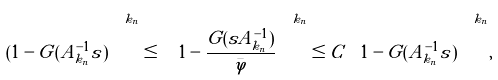<formula> <loc_0><loc_0><loc_500><loc_500>( 1 - \tilde { G } ( A _ { k _ { n } } ^ { - 1 } s ) \Big ) ^ { k _ { n } } \leq \Big ( 1 - \frac { G ( s A _ { k _ { n } } ^ { - 1 } ) } { \bar { \varphi } } \Big ) ^ { k _ { n } } \leq C \Big ( 1 - \tilde { G } ( A _ { k _ { n } } ^ { - 1 } s ) \Big ) ^ { k _ { n } } ,</formula> 